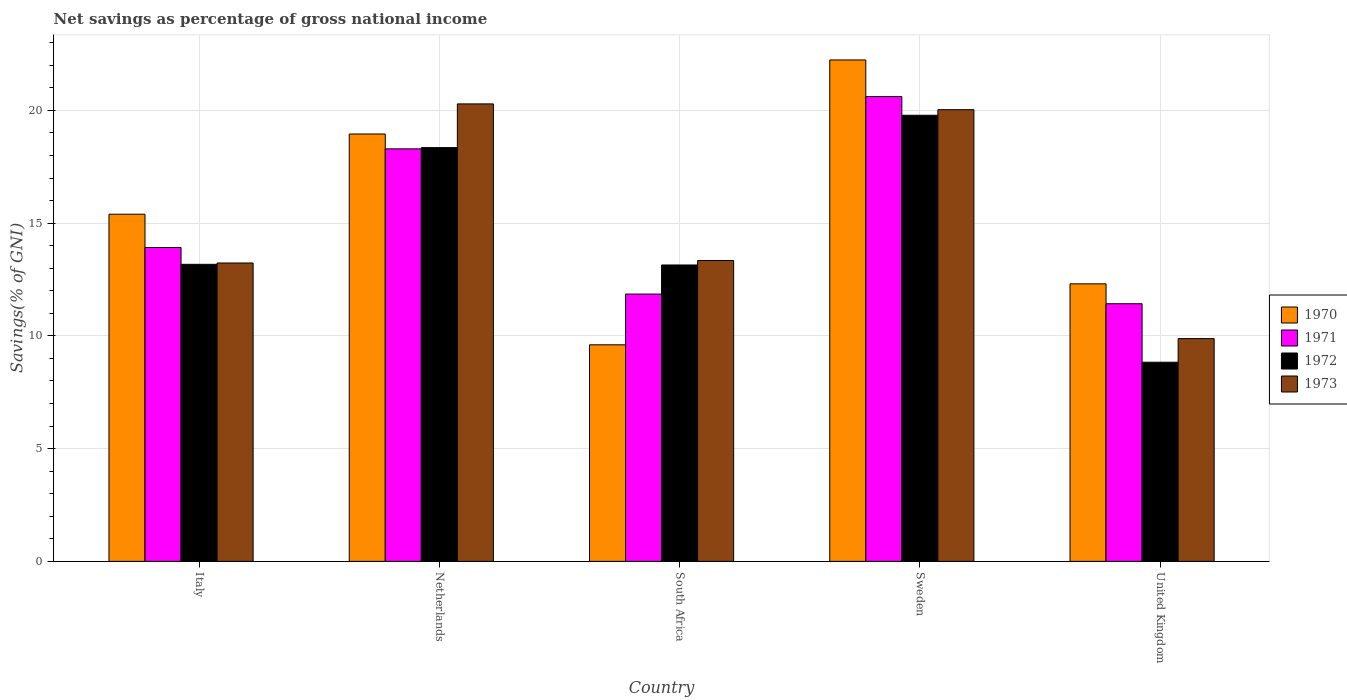Are the number of bars per tick equal to the number of legend labels?
Offer a very short reply. Yes. How many bars are there on the 5th tick from the right?
Give a very brief answer. 4. What is the total savings in 1972 in United Kingdom?
Offer a very short reply. 8.83. Across all countries, what is the maximum total savings in 1973?
Give a very brief answer. 20.29. Across all countries, what is the minimum total savings in 1973?
Ensure brevity in your answer.  9.88. In which country was the total savings in 1970 minimum?
Give a very brief answer. South Africa. What is the total total savings in 1970 in the graph?
Offer a very short reply. 78.5. What is the difference between the total savings in 1972 in Netherlands and that in United Kingdom?
Ensure brevity in your answer.  9.52. What is the difference between the total savings in 1970 in Sweden and the total savings in 1972 in Netherlands?
Offer a terse response. 3.89. What is the average total savings in 1970 per country?
Give a very brief answer. 15.7. What is the difference between the total savings of/in 1972 and total savings of/in 1970 in Italy?
Offer a very short reply. -2.22. What is the ratio of the total savings in 1970 in Netherlands to that in United Kingdom?
Offer a very short reply. 1.54. Is the total savings in 1970 in South Africa less than that in United Kingdom?
Provide a succinct answer. Yes. Is the difference between the total savings in 1972 in Sweden and United Kingdom greater than the difference between the total savings in 1970 in Sweden and United Kingdom?
Give a very brief answer. Yes. What is the difference between the highest and the second highest total savings in 1970?
Ensure brevity in your answer.  -3.28. What is the difference between the highest and the lowest total savings in 1972?
Ensure brevity in your answer.  10.95. In how many countries, is the total savings in 1970 greater than the average total savings in 1970 taken over all countries?
Offer a terse response. 2. Is it the case that in every country, the sum of the total savings in 1973 and total savings in 1971 is greater than the sum of total savings in 1972 and total savings in 1970?
Provide a short and direct response. No. What does the 4th bar from the left in South Africa represents?
Offer a terse response. 1973. What does the 4th bar from the right in South Africa represents?
Provide a short and direct response. 1970. How many bars are there?
Give a very brief answer. 20. What is the difference between two consecutive major ticks on the Y-axis?
Provide a short and direct response. 5. Where does the legend appear in the graph?
Ensure brevity in your answer.  Center right. How many legend labels are there?
Keep it short and to the point. 4. What is the title of the graph?
Ensure brevity in your answer.  Net savings as percentage of gross national income. What is the label or title of the X-axis?
Your response must be concise. Country. What is the label or title of the Y-axis?
Offer a very short reply. Savings(% of GNI). What is the Savings(% of GNI) in 1970 in Italy?
Your answer should be compact. 15.4. What is the Savings(% of GNI) of 1971 in Italy?
Ensure brevity in your answer.  13.92. What is the Savings(% of GNI) of 1972 in Italy?
Ensure brevity in your answer.  13.17. What is the Savings(% of GNI) in 1973 in Italy?
Provide a short and direct response. 13.23. What is the Savings(% of GNI) of 1970 in Netherlands?
Your response must be concise. 18.95. What is the Savings(% of GNI) of 1971 in Netherlands?
Give a very brief answer. 18.29. What is the Savings(% of GNI) of 1972 in Netherlands?
Offer a terse response. 18.35. What is the Savings(% of GNI) of 1973 in Netherlands?
Make the answer very short. 20.29. What is the Savings(% of GNI) of 1970 in South Africa?
Offer a terse response. 9.6. What is the Savings(% of GNI) in 1971 in South Africa?
Offer a terse response. 11.85. What is the Savings(% of GNI) of 1972 in South Africa?
Offer a very short reply. 13.14. What is the Savings(% of GNI) of 1973 in South Africa?
Keep it short and to the point. 13.34. What is the Savings(% of GNI) of 1970 in Sweden?
Your answer should be very brief. 22.24. What is the Savings(% of GNI) in 1971 in Sweden?
Provide a succinct answer. 20.61. What is the Savings(% of GNI) of 1972 in Sweden?
Ensure brevity in your answer.  19.78. What is the Savings(% of GNI) of 1973 in Sweden?
Your response must be concise. 20.03. What is the Savings(% of GNI) in 1970 in United Kingdom?
Provide a succinct answer. 12.31. What is the Savings(% of GNI) in 1971 in United Kingdom?
Ensure brevity in your answer.  11.43. What is the Savings(% of GNI) of 1972 in United Kingdom?
Your answer should be compact. 8.83. What is the Savings(% of GNI) of 1973 in United Kingdom?
Your answer should be very brief. 9.88. Across all countries, what is the maximum Savings(% of GNI) in 1970?
Offer a very short reply. 22.24. Across all countries, what is the maximum Savings(% of GNI) of 1971?
Make the answer very short. 20.61. Across all countries, what is the maximum Savings(% of GNI) in 1972?
Provide a short and direct response. 19.78. Across all countries, what is the maximum Savings(% of GNI) in 1973?
Your response must be concise. 20.29. Across all countries, what is the minimum Savings(% of GNI) of 1970?
Provide a succinct answer. 9.6. Across all countries, what is the minimum Savings(% of GNI) of 1971?
Provide a succinct answer. 11.43. Across all countries, what is the minimum Savings(% of GNI) of 1972?
Provide a succinct answer. 8.83. Across all countries, what is the minimum Savings(% of GNI) in 1973?
Offer a terse response. 9.88. What is the total Savings(% of GNI) of 1970 in the graph?
Give a very brief answer. 78.5. What is the total Savings(% of GNI) of 1971 in the graph?
Provide a short and direct response. 76.1. What is the total Savings(% of GNI) in 1972 in the graph?
Keep it short and to the point. 73.28. What is the total Savings(% of GNI) of 1973 in the graph?
Provide a short and direct response. 76.77. What is the difference between the Savings(% of GNI) in 1970 in Italy and that in Netherlands?
Your response must be concise. -3.56. What is the difference between the Savings(% of GNI) in 1971 in Italy and that in Netherlands?
Make the answer very short. -4.37. What is the difference between the Savings(% of GNI) in 1972 in Italy and that in Netherlands?
Your answer should be very brief. -5.18. What is the difference between the Savings(% of GNI) of 1973 in Italy and that in Netherlands?
Provide a succinct answer. -7.06. What is the difference between the Savings(% of GNI) in 1970 in Italy and that in South Africa?
Ensure brevity in your answer.  5.79. What is the difference between the Savings(% of GNI) in 1971 in Italy and that in South Africa?
Give a very brief answer. 2.07. What is the difference between the Savings(% of GNI) in 1972 in Italy and that in South Africa?
Provide a succinct answer. 0.03. What is the difference between the Savings(% of GNI) in 1973 in Italy and that in South Africa?
Provide a succinct answer. -0.11. What is the difference between the Savings(% of GNI) of 1970 in Italy and that in Sweden?
Give a very brief answer. -6.84. What is the difference between the Savings(% of GNI) in 1971 in Italy and that in Sweden?
Offer a very short reply. -6.69. What is the difference between the Savings(% of GNI) in 1972 in Italy and that in Sweden?
Ensure brevity in your answer.  -6.61. What is the difference between the Savings(% of GNI) of 1973 in Italy and that in Sweden?
Provide a succinct answer. -6.8. What is the difference between the Savings(% of GNI) in 1970 in Italy and that in United Kingdom?
Your answer should be very brief. 3.09. What is the difference between the Savings(% of GNI) in 1971 in Italy and that in United Kingdom?
Make the answer very short. 2.49. What is the difference between the Savings(% of GNI) in 1972 in Italy and that in United Kingdom?
Offer a very short reply. 4.34. What is the difference between the Savings(% of GNI) of 1973 in Italy and that in United Kingdom?
Your answer should be compact. 3.35. What is the difference between the Savings(% of GNI) of 1970 in Netherlands and that in South Africa?
Offer a very short reply. 9.35. What is the difference between the Savings(% of GNI) of 1971 in Netherlands and that in South Africa?
Provide a succinct answer. 6.44. What is the difference between the Savings(% of GNI) in 1972 in Netherlands and that in South Africa?
Your answer should be compact. 5.21. What is the difference between the Savings(% of GNI) of 1973 in Netherlands and that in South Africa?
Offer a terse response. 6.95. What is the difference between the Savings(% of GNI) in 1970 in Netherlands and that in Sweden?
Your response must be concise. -3.28. What is the difference between the Savings(% of GNI) in 1971 in Netherlands and that in Sweden?
Offer a very short reply. -2.32. What is the difference between the Savings(% of GNI) of 1972 in Netherlands and that in Sweden?
Your response must be concise. -1.43. What is the difference between the Savings(% of GNI) of 1973 in Netherlands and that in Sweden?
Give a very brief answer. 0.26. What is the difference between the Savings(% of GNI) in 1970 in Netherlands and that in United Kingdom?
Ensure brevity in your answer.  6.65. What is the difference between the Savings(% of GNI) of 1971 in Netherlands and that in United Kingdom?
Offer a very short reply. 6.87. What is the difference between the Savings(% of GNI) in 1972 in Netherlands and that in United Kingdom?
Keep it short and to the point. 9.52. What is the difference between the Savings(% of GNI) of 1973 in Netherlands and that in United Kingdom?
Make the answer very short. 10.41. What is the difference between the Savings(% of GNI) in 1970 in South Africa and that in Sweden?
Offer a very short reply. -12.63. What is the difference between the Savings(% of GNI) of 1971 in South Africa and that in Sweden?
Your answer should be very brief. -8.76. What is the difference between the Savings(% of GNI) of 1972 in South Africa and that in Sweden?
Make the answer very short. -6.64. What is the difference between the Savings(% of GNI) in 1973 in South Africa and that in Sweden?
Offer a very short reply. -6.69. What is the difference between the Savings(% of GNI) of 1970 in South Africa and that in United Kingdom?
Provide a succinct answer. -2.7. What is the difference between the Savings(% of GNI) of 1971 in South Africa and that in United Kingdom?
Your answer should be compact. 0.43. What is the difference between the Savings(% of GNI) in 1972 in South Africa and that in United Kingdom?
Give a very brief answer. 4.31. What is the difference between the Savings(% of GNI) of 1973 in South Africa and that in United Kingdom?
Ensure brevity in your answer.  3.46. What is the difference between the Savings(% of GNI) of 1970 in Sweden and that in United Kingdom?
Ensure brevity in your answer.  9.93. What is the difference between the Savings(% of GNI) in 1971 in Sweden and that in United Kingdom?
Offer a very short reply. 9.19. What is the difference between the Savings(% of GNI) in 1972 in Sweden and that in United Kingdom?
Ensure brevity in your answer.  10.95. What is the difference between the Savings(% of GNI) in 1973 in Sweden and that in United Kingdom?
Keep it short and to the point. 10.15. What is the difference between the Savings(% of GNI) in 1970 in Italy and the Savings(% of GNI) in 1971 in Netherlands?
Offer a very short reply. -2.9. What is the difference between the Savings(% of GNI) in 1970 in Italy and the Savings(% of GNI) in 1972 in Netherlands?
Provide a succinct answer. -2.95. What is the difference between the Savings(% of GNI) in 1970 in Italy and the Savings(% of GNI) in 1973 in Netherlands?
Offer a very short reply. -4.89. What is the difference between the Savings(% of GNI) of 1971 in Italy and the Savings(% of GNI) of 1972 in Netherlands?
Offer a very short reply. -4.43. What is the difference between the Savings(% of GNI) of 1971 in Italy and the Savings(% of GNI) of 1973 in Netherlands?
Provide a short and direct response. -6.37. What is the difference between the Savings(% of GNI) in 1972 in Italy and the Savings(% of GNI) in 1973 in Netherlands?
Your answer should be compact. -7.11. What is the difference between the Savings(% of GNI) of 1970 in Italy and the Savings(% of GNI) of 1971 in South Africa?
Ensure brevity in your answer.  3.54. What is the difference between the Savings(% of GNI) of 1970 in Italy and the Savings(% of GNI) of 1972 in South Africa?
Provide a short and direct response. 2.25. What is the difference between the Savings(% of GNI) of 1970 in Italy and the Savings(% of GNI) of 1973 in South Africa?
Make the answer very short. 2.05. What is the difference between the Savings(% of GNI) of 1971 in Italy and the Savings(% of GNI) of 1972 in South Africa?
Give a very brief answer. 0.78. What is the difference between the Savings(% of GNI) in 1971 in Italy and the Savings(% of GNI) in 1973 in South Africa?
Your answer should be very brief. 0.58. What is the difference between the Savings(% of GNI) of 1972 in Italy and the Savings(% of GNI) of 1973 in South Africa?
Ensure brevity in your answer.  -0.17. What is the difference between the Savings(% of GNI) of 1970 in Italy and the Savings(% of GNI) of 1971 in Sweden?
Your response must be concise. -5.22. What is the difference between the Savings(% of GNI) of 1970 in Italy and the Savings(% of GNI) of 1972 in Sweden?
Your response must be concise. -4.39. What is the difference between the Savings(% of GNI) in 1970 in Italy and the Savings(% of GNI) in 1973 in Sweden?
Make the answer very short. -4.64. What is the difference between the Savings(% of GNI) in 1971 in Italy and the Savings(% of GNI) in 1972 in Sweden?
Your answer should be compact. -5.86. What is the difference between the Savings(% of GNI) in 1971 in Italy and the Savings(% of GNI) in 1973 in Sweden?
Your answer should be very brief. -6.11. What is the difference between the Savings(% of GNI) of 1972 in Italy and the Savings(% of GNI) of 1973 in Sweden?
Your answer should be compact. -6.86. What is the difference between the Savings(% of GNI) of 1970 in Italy and the Savings(% of GNI) of 1971 in United Kingdom?
Provide a short and direct response. 3.97. What is the difference between the Savings(% of GNI) of 1970 in Italy and the Savings(% of GNI) of 1972 in United Kingdom?
Ensure brevity in your answer.  6.56. What is the difference between the Savings(% of GNI) of 1970 in Italy and the Savings(% of GNI) of 1973 in United Kingdom?
Offer a very short reply. 5.52. What is the difference between the Savings(% of GNI) in 1971 in Italy and the Savings(% of GNI) in 1972 in United Kingdom?
Provide a succinct answer. 5.09. What is the difference between the Savings(% of GNI) of 1971 in Italy and the Savings(% of GNI) of 1973 in United Kingdom?
Your response must be concise. 4.04. What is the difference between the Savings(% of GNI) in 1972 in Italy and the Savings(% of GNI) in 1973 in United Kingdom?
Make the answer very short. 3.3. What is the difference between the Savings(% of GNI) in 1970 in Netherlands and the Savings(% of GNI) in 1971 in South Africa?
Your response must be concise. 7.1. What is the difference between the Savings(% of GNI) in 1970 in Netherlands and the Savings(% of GNI) in 1972 in South Africa?
Your answer should be very brief. 5.81. What is the difference between the Savings(% of GNI) in 1970 in Netherlands and the Savings(% of GNI) in 1973 in South Africa?
Your answer should be compact. 5.61. What is the difference between the Savings(% of GNI) of 1971 in Netherlands and the Savings(% of GNI) of 1972 in South Africa?
Offer a terse response. 5.15. What is the difference between the Savings(% of GNI) in 1971 in Netherlands and the Savings(% of GNI) in 1973 in South Africa?
Make the answer very short. 4.95. What is the difference between the Savings(% of GNI) of 1972 in Netherlands and the Savings(% of GNI) of 1973 in South Africa?
Offer a terse response. 5.01. What is the difference between the Savings(% of GNI) in 1970 in Netherlands and the Savings(% of GNI) in 1971 in Sweden?
Provide a short and direct response. -1.66. What is the difference between the Savings(% of GNI) in 1970 in Netherlands and the Savings(% of GNI) in 1972 in Sweden?
Give a very brief answer. -0.83. What is the difference between the Savings(% of GNI) in 1970 in Netherlands and the Savings(% of GNI) in 1973 in Sweden?
Provide a succinct answer. -1.08. What is the difference between the Savings(% of GNI) in 1971 in Netherlands and the Savings(% of GNI) in 1972 in Sweden?
Keep it short and to the point. -1.49. What is the difference between the Savings(% of GNI) in 1971 in Netherlands and the Savings(% of GNI) in 1973 in Sweden?
Your answer should be very brief. -1.74. What is the difference between the Savings(% of GNI) of 1972 in Netherlands and the Savings(% of GNI) of 1973 in Sweden?
Provide a short and direct response. -1.68. What is the difference between the Savings(% of GNI) of 1970 in Netherlands and the Savings(% of GNI) of 1971 in United Kingdom?
Ensure brevity in your answer.  7.53. What is the difference between the Savings(% of GNI) in 1970 in Netherlands and the Savings(% of GNI) in 1972 in United Kingdom?
Keep it short and to the point. 10.12. What is the difference between the Savings(% of GNI) in 1970 in Netherlands and the Savings(% of GNI) in 1973 in United Kingdom?
Make the answer very short. 9.07. What is the difference between the Savings(% of GNI) of 1971 in Netherlands and the Savings(% of GNI) of 1972 in United Kingdom?
Offer a very short reply. 9.46. What is the difference between the Savings(% of GNI) of 1971 in Netherlands and the Savings(% of GNI) of 1973 in United Kingdom?
Your answer should be very brief. 8.42. What is the difference between the Savings(% of GNI) of 1972 in Netherlands and the Savings(% of GNI) of 1973 in United Kingdom?
Your answer should be very brief. 8.47. What is the difference between the Savings(% of GNI) in 1970 in South Africa and the Savings(% of GNI) in 1971 in Sweden?
Provide a short and direct response. -11.01. What is the difference between the Savings(% of GNI) in 1970 in South Africa and the Savings(% of GNI) in 1972 in Sweden?
Your answer should be compact. -10.18. What is the difference between the Savings(% of GNI) of 1970 in South Africa and the Savings(% of GNI) of 1973 in Sweden?
Make the answer very short. -10.43. What is the difference between the Savings(% of GNI) of 1971 in South Africa and the Savings(% of GNI) of 1972 in Sweden?
Your response must be concise. -7.93. What is the difference between the Savings(% of GNI) of 1971 in South Africa and the Savings(% of GNI) of 1973 in Sweden?
Provide a succinct answer. -8.18. What is the difference between the Savings(% of GNI) of 1972 in South Africa and the Savings(% of GNI) of 1973 in Sweden?
Keep it short and to the point. -6.89. What is the difference between the Savings(% of GNI) in 1970 in South Africa and the Savings(% of GNI) in 1971 in United Kingdom?
Ensure brevity in your answer.  -1.82. What is the difference between the Savings(% of GNI) of 1970 in South Africa and the Savings(% of GNI) of 1972 in United Kingdom?
Provide a succinct answer. 0.77. What is the difference between the Savings(% of GNI) of 1970 in South Africa and the Savings(% of GNI) of 1973 in United Kingdom?
Provide a short and direct response. -0.27. What is the difference between the Savings(% of GNI) of 1971 in South Africa and the Savings(% of GNI) of 1972 in United Kingdom?
Offer a very short reply. 3.02. What is the difference between the Savings(% of GNI) in 1971 in South Africa and the Savings(% of GNI) in 1973 in United Kingdom?
Your answer should be very brief. 1.98. What is the difference between the Savings(% of GNI) of 1972 in South Africa and the Savings(% of GNI) of 1973 in United Kingdom?
Your response must be concise. 3.27. What is the difference between the Savings(% of GNI) of 1970 in Sweden and the Savings(% of GNI) of 1971 in United Kingdom?
Your response must be concise. 10.81. What is the difference between the Savings(% of GNI) of 1970 in Sweden and the Savings(% of GNI) of 1972 in United Kingdom?
Your answer should be very brief. 13.41. What is the difference between the Savings(% of GNI) in 1970 in Sweden and the Savings(% of GNI) in 1973 in United Kingdom?
Give a very brief answer. 12.36. What is the difference between the Savings(% of GNI) in 1971 in Sweden and the Savings(% of GNI) in 1972 in United Kingdom?
Offer a very short reply. 11.78. What is the difference between the Savings(% of GNI) of 1971 in Sweden and the Savings(% of GNI) of 1973 in United Kingdom?
Your answer should be compact. 10.73. What is the difference between the Savings(% of GNI) in 1972 in Sweden and the Savings(% of GNI) in 1973 in United Kingdom?
Ensure brevity in your answer.  9.91. What is the average Savings(% of GNI) of 1970 per country?
Make the answer very short. 15.7. What is the average Savings(% of GNI) of 1971 per country?
Ensure brevity in your answer.  15.22. What is the average Savings(% of GNI) in 1972 per country?
Give a very brief answer. 14.66. What is the average Savings(% of GNI) in 1973 per country?
Your answer should be very brief. 15.35. What is the difference between the Savings(% of GNI) of 1970 and Savings(% of GNI) of 1971 in Italy?
Keep it short and to the point. 1.48. What is the difference between the Savings(% of GNI) of 1970 and Savings(% of GNI) of 1972 in Italy?
Give a very brief answer. 2.22. What is the difference between the Savings(% of GNI) of 1970 and Savings(% of GNI) of 1973 in Italy?
Your answer should be compact. 2.16. What is the difference between the Savings(% of GNI) of 1971 and Savings(% of GNI) of 1972 in Italy?
Give a very brief answer. 0.75. What is the difference between the Savings(% of GNI) of 1971 and Savings(% of GNI) of 1973 in Italy?
Make the answer very short. 0.69. What is the difference between the Savings(% of GNI) of 1972 and Savings(% of GNI) of 1973 in Italy?
Give a very brief answer. -0.06. What is the difference between the Savings(% of GNI) of 1970 and Savings(% of GNI) of 1971 in Netherlands?
Ensure brevity in your answer.  0.66. What is the difference between the Savings(% of GNI) of 1970 and Savings(% of GNI) of 1972 in Netherlands?
Offer a very short reply. 0.6. What is the difference between the Savings(% of GNI) in 1970 and Savings(% of GNI) in 1973 in Netherlands?
Offer a terse response. -1.33. What is the difference between the Savings(% of GNI) of 1971 and Savings(% of GNI) of 1972 in Netherlands?
Provide a short and direct response. -0.06. What is the difference between the Savings(% of GNI) in 1971 and Savings(% of GNI) in 1973 in Netherlands?
Give a very brief answer. -1.99. What is the difference between the Savings(% of GNI) in 1972 and Savings(% of GNI) in 1973 in Netherlands?
Make the answer very short. -1.94. What is the difference between the Savings(% of GNI) of 1970 and Savings(% of GNI) of 1971 in South Africa?
Offer a terse response. -2.25. What is the difference between the Savings(% of GNI) in 1970 and Savings(% of GNI) in 1972 in South Africa?
Your answer should be very brief. -3.54. What is the difference between the Savings(% of GNI) of 1970 and Savings(% of GNI) of 1973 in South Africa?
Provide a succinct answer. -3.74. What is the difference between the Savings(% of GNI) in 1971 and Savings(% of GNI) in 1972 in South Africa?
Provide a short and direct response. -1.29. What is the difference between the Savings(% of GNI) in 1971 and Savings(% of GNI) in 1973 in South Africa?
Your response must be concise. -1.49. What is the difference between the Savings(% of GNI) of 1972 and Savings(% of GNI) of 1973 in South Africa?
Provide a succinct answer. -0.2. What is the difference between the Savings(% of GNI) of 1970 and Savings(% of GNI) of 1971 in Sweden?
Ensure brevity in your answer.  1.62. What is the difference between the Savings(% of GNI) in 1970 and Savings(% of GNI) in 1972 in Sweden?
Keep it short and to the point. 2.45. What is the difference between the Savings(% of GNI) of 1970 and Savings(% of GNI) of 1973 in Sweden?
Keep it short and to the point. 2.21. What is the difference between the Savings(% of GNI) of 1971 and Savings(% of GNI) of 1972 in Sweden?
Make the answer very short. 0.83. What is the difference between the Savings(% of GNI) in 1971 and Savings(% of GNI) in 1973 in Sweden?
Provide a succinct answer. 0.58. What is the difference between the Savings(% of GNI) of 1972 and Savings(% of GNI) of 1973 in Sweden?
Provide a short and direct response. -0.25. What is the difference between the Savings(% of GNI) of 1970 and Savings(% of GNI) of 1971 in United Kingdom?
Your answer should be compact. 0.88. What is the difference between the Savings(% of GNI) of 1970 and Savings(% of GNI) of 1972 in United Kingdom?
Your answer should be compact. 3.48. What is the difference between the Savings(% of GNI) of 1970 and Savings(% of GNI) of 1973 in United Kingdom?
Your answer should be compact. 2.43. What is the difference between the Savings(% of GNI) in 1971 and Savings(% of GNI) in 1972 in United Kingdom?
Make the answer very short. 2.59. What is the difference between the Savings(% of GNI) of 1971 and Savings(% of GNI) of 1973 in United Kingdom?
Keep it short and to the point. 1.55. What is the difference between the Savings(% of GNI) of 1972 and Savings(% of GNI) of 1973 in United Kingdom?
Make the answer very short. -1.05. What is the ratio of the Savings(% of GNI) of 1970 in Italy to that in Netherlands?
Your answer should be very brief. 0.81. What is the ratio of the Savings(% of GNI) in 1971 in Italy to that in Netherlands?
Ensure brevity in your answer.  0.76. What is the ratio of the Savings(% of GNI) of 1972 in Italy to that in Netherlands?
Your response must be concise. 0.72. What is the ratio of the Savings(% of GNI) in 1973 in Italy to that in Netherlands?
Make the answer very short. 0.65. What is the ratio of the Savings(% of GNI) in 1970 in Italy to that in South Africa?
Give a very brief answer. 1.6. What is the ratio of the Savings(% of GNI) in 1971 in Italy to that in South Africa?
Make the answer very short. 1.17. What is the ratio of the Savings(% of GNI) of 1973 in Italy to that in South Africa?
Your response must be concise. 0.99. What is the ratio of the Savings(% of GNI) in 1970 in Italy to that in Sweden?
Your answer should be compact. 0.69. What is the ratio of the Savings(% of GNI) of 1971 in Italy to that in Sweden?
Offer a very short reply. 0.68. What is the ratio of the Savings(% of GNI) of 1972 in Italy to that in Sweden?
Your response must be concise. 0.67. What is the ratio of the Savings(% of GNI) in 1973 in Italy to that in Sweden?
Provide a short and direct response. 0.66. What is the ratio of the Savings(% of GNI) of 1970 in Italy to that in United Kingdom?
Your answer should be very brief. 1.25. What is the ratio of the Savings(% of GNI) in 1971 in Italy to that in United Kingdom?
Give a very brief answer. 1.22. What is the ratio of the Savings(% of GNI) in 1972 in Italy to that in United Kingdom?
Your answer should be compact. 1.49. What is the ratio of the Savings(% of GNI) of 1973 in Italy to that in United Kingdom?
Provide a short and direct response. 1.34. What is the ratio of the Savings(% of GNI) in 1970 in Netherlands to that in South Africa?
Keep it short and to the point. 1.97. What is the ratio of the Savings(% of GNI) in 1971 in Netherlands to that in South Africa?
Offer a terse response. 1.54. What is the ratio of the Savings(% of GNI) of 1972 in Netherlands to that in South Africa?
Keep it short and to the point. 1.4. What is the ratio of the Savings(% of GNI) in 1973 in Netherlands to that in South Africa?
Your answer should be very brief. 1.52. What is the ratio of the Savings(% of GNI) of 1970 in Netherlands to that in Sweden?
Give a very brief answer. 0.85. What is the ratio of the Savings(% of GNI) of 1971 in Netherlands to that in Sweden?
Offer a very short reply. 0.89. What is the ratio of the Savings(% of GNI) of 1972 in Netherlands to that in Sweden?
Your response must be concise. 0.93. What is the ratio of the Savings(% of GNI) in 1973 in Netherlands to that in Sweden?
Offer a terse response. 1.01. What is the ratio of the Savings(% of GNI) of 1970 in Netherlands to that in United Kingdom?
Your answer should be compact. 1.54. What is the ratio of the Savings(% of GNI) in 1971 in Netherlands to that in United Kingdom?
Offer a very short reply. 1.6. What is the ratio of the Savings(% of GNI) in 1972 in Netherlands to that in United Kingdom?
Your response must be concise. 2.08. What is the ratio of the Savings(% of GNI) of 1973 in Netherlands to that in United Kingdom?
Your answer should be very brief. 2.05. What is the ratio of the Savings(% of GNI) of 1970 in South Africa to that in Sweden?
Your response must be concise. 0.43. What is the ratio of the Savings(% of GNI) of 1971 in South Africa to that in Sweden?
Offer a very short reply. 0.58. What is the ratio of the Savings(% of GNI) of 1972 in South Africa to that in Sweden?
Make the answer very short. 0.66. What is the ratio of the Savings(% of GNI) in 1973 in South Africa to that in Sweden?
Provide a short and direct response. 0.67. What is the ratio of the Savings(% of GNI) in 1970 in South Africa to that in United Kingdom?
Ensure brevity in your answer.  0.78. What is the ratio of the Savings(% of GNI) of 1971 in South Africa to that in United Kingdom?
Make the answer very short. 1.04. What is the ratio of the Savings(% of GNI) of 1972 in South Africa to that in United Kingdom?
Provide a short and direct response. 1.49. What is the ratio of the Savings(% of GNI) in 1973 in South Africa to that in United Kingdom?
Make the answer very short. 1.35. What is the ratio of the Savings(% of GNI) of 1970 in Sweden to that in United Kingdom?
Ensure brevity in your answer.  1.81. What is the ratio of the Savings(% of GNI) of 1971 in Sweden to that in United Kingdom?
Make the answer very short. 1.8. What is the ratio of the Savings(% of GNI) in 1972 in Sweden to that in United Kingdom?
Make the answer very short. 2.24. What is the ratio of the Savings(% of GNI) of 1973 in Sweden to that in United Kingdom?
Your response must be concise. 2.03. What is the difference between the highest and the second highest Savings(% of GNI) in 1970?
Provide a succinct answer. 3.28. What is the difference between the highest and the second highest Savings(% of GNI) of 1971?
Give a very brief answer. 2.32. What is the difference between the highest and the second highest Savings(% of GNI) in 1972?
Offer a very short reply. 1.43. What is the difference between the highest and the second highest Savings(% of GNI) of 1973?
Provide a short and direct response. 0.26. What is the difference between the highest and the lowest Savings(% of GNI) of 1970?
Ensure brevity in your answer.  12.63. What is the difference between the highest and the lowest Savings(% of GNI) of 1971?
Ensure brevity in your answer.  9.19. What is the difference between the highest and the lowest Savings(% of GNI) in 1972?
Your response must be concise. 10.95. What is the difference between the highest and the lowest Savings(% of GNI) in 1973?
Offer a terse response. 10.41. 